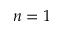Convert formula to latex. <formula><loc_0><loc_0><loc_500><loc_500>n = 1</formula> 